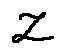<formula> <loc_0><loc_0><loc_500><loc_500>z</formula> 